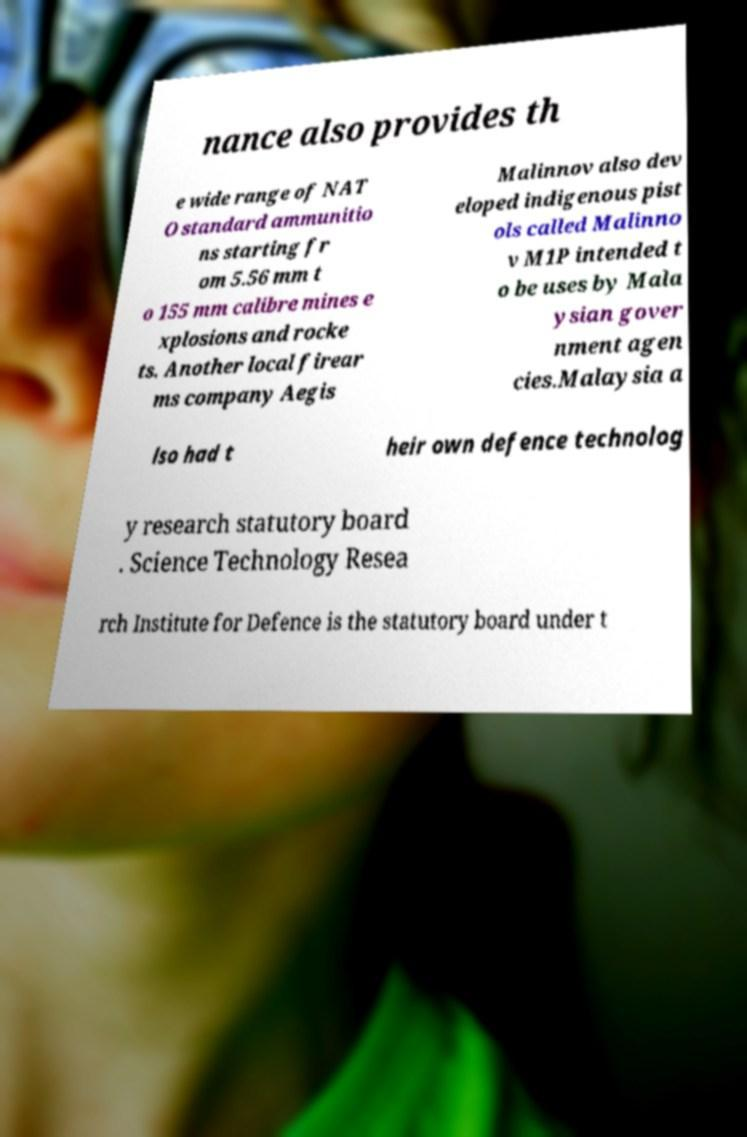I need the written content from this picture converted into text. Can you do that? nance also provides th e wide range of NAT O standard ammunitio ns starting fr om 5.56 mm t o 155 mm calibre mines e xplosions and rocke ts. Another local firear ms company Aegis Malinnov also dev eloped indigenous pist ols called Malinno v M1P intended t o be uses by Mala ysian gover nment agen cies.Malaysia a lso had t heir own defence technolog y research statutory board . Science Technology Resea rch Institute for Defence is the statutory board under t 